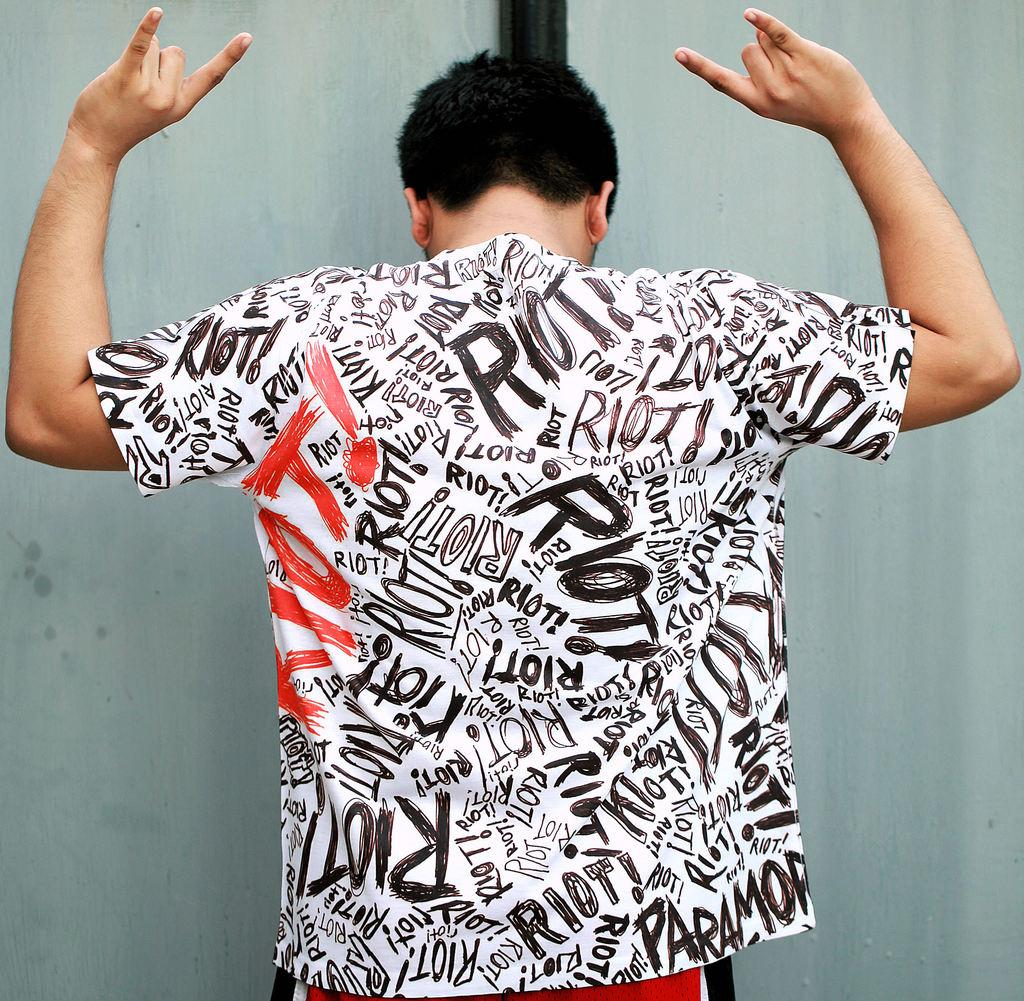<image>
Create a compact narrative representing the image presented. A black, white, and red shirt that has the word riot all over it. 